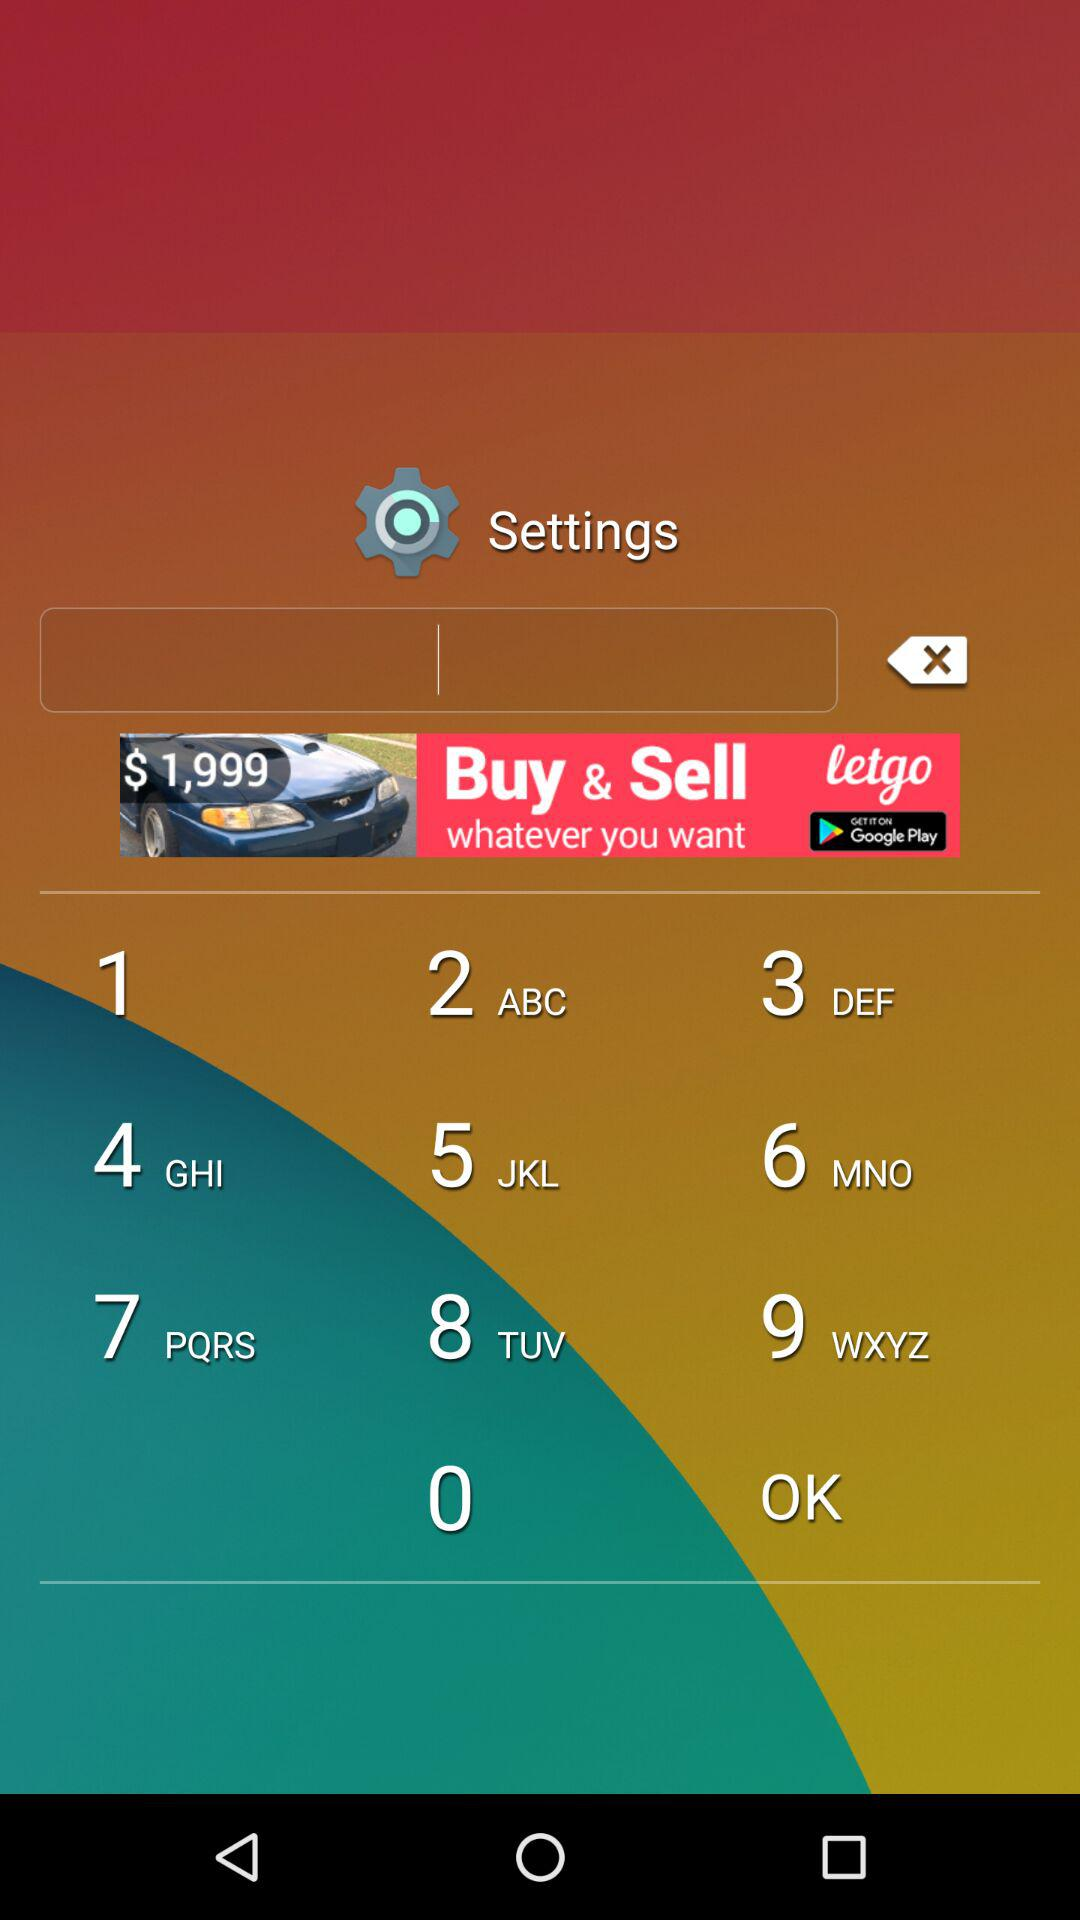How many credits are there in the credits section?
Answer the question using a single word or phrase. 5 